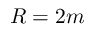Convert formula to latex. <formula><loc_0><loc_0><loc_500><loc_500>R = 2 m</formula> 